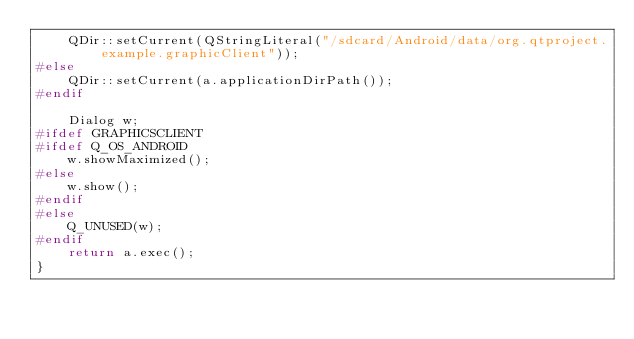<code> <loc_0><loc_0><loc_500><loc_500><_C++_>    QDir::setCurrent(QStringLiteral("/sdcard/Android/data/org.qtproject.example.graphicClient"));
#else
    QDir::setCurrent(a.applicationDirPath());
#endif

    Dialog w;
#ifdef GRAPHICSCLIENT
#ifdef Q_OS_ANDROID
    w.showMaximized();
#else
    w.show();
#endif
#else
    Q_UNUSED(w);
#endif
    return a.exec();
}
</code> 